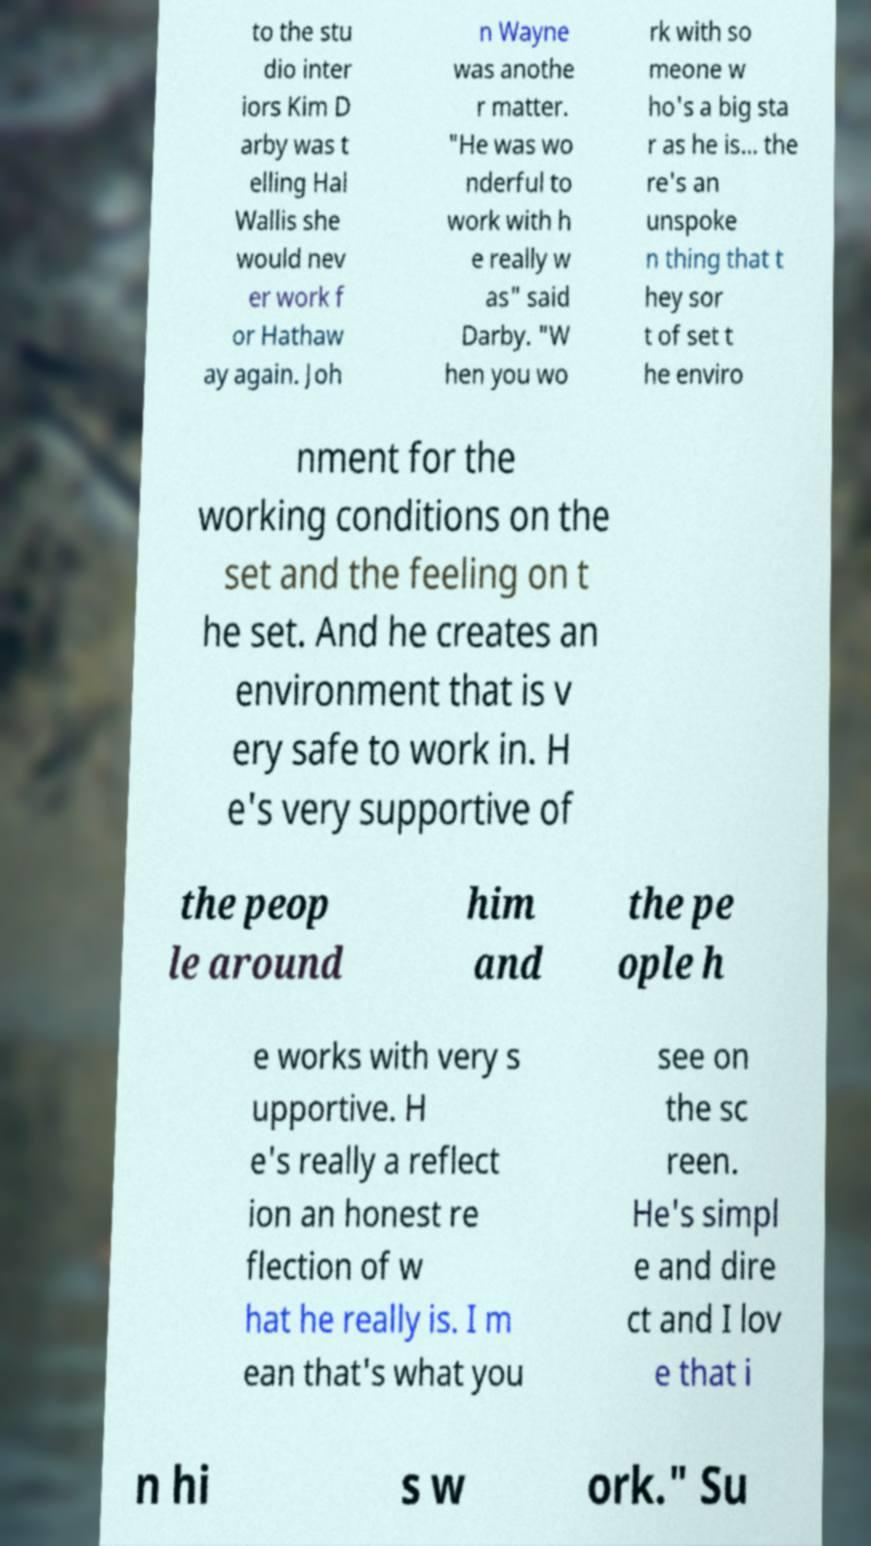There's text embedded in this image that I need extracted. Can you transcribe it verbatim? to the stu dio inter iors Kim D arby was t elling Hal Wallis she would nev er work f or Hathaw ay again. Joh n Wayne was anothe r matter. "He was wo nderful to work with h e really w as" said Darby. "W hen you wo rk with so meone w ho's a big sta r as he is... the re's an unspoke n thing that t hey sor t of set t he enviro nment for the working conditions on the set and the feeling on t he set. And he creates an environment that is v ery safe to work in. H e's very supportive of the peop le around him and the pe ople h e works with very s upportive. H e's really a reflect ion an honest re flection of w hat he really is. I m ean that's what you see on the sc reen. He's simpl e and dire ct and I lov e that i n hi s w ork." Su 